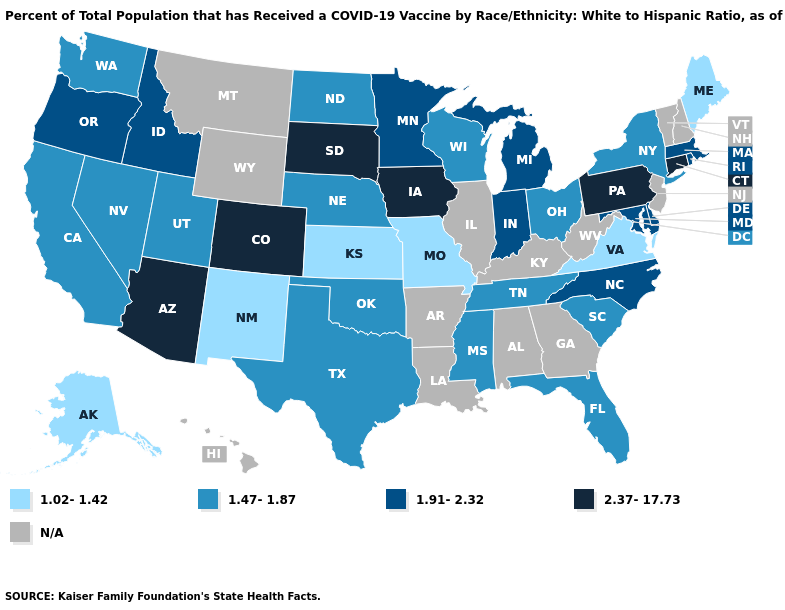What is the lowest value in the West?
Quick response, please. 1.02-1.42. How many symbols are there in the legend?
Keep it brief. 5. Among the states that border Kentucky , does Ohio have the lowest value?
Short answer required. No. What is the value of Massachusetts?
Keep it brief. 1.91-2.32. What is the value of Minnesota?
Give a very brief answer. 1.91-2.32. What is the lowest value in the South?
Write a very short answer. 1.02-1.42. Name the states that have a value in the range N/A?
Write a very short answer. Alabama, Arkansas, Georgia, Hawaii, Illinois, Kentucky, Louisiana, Montana, New Hampshire, New Jersey, Vermont, West Virginia, Wyoming. What is the value of Pennsylvania?
Give a very brief answer. 2.37-17.73. Name the states that have a value in the range 1.02-1.42?
Quick response, please. Alaska, Kansas, Maine, Missouri, New Mexico, Virginia. Which states have the lowest value in the West?
Concise answer only. Alaska, New Mexico. Does Virginia have the lowest value in the South?
Short answer required. Yes. 